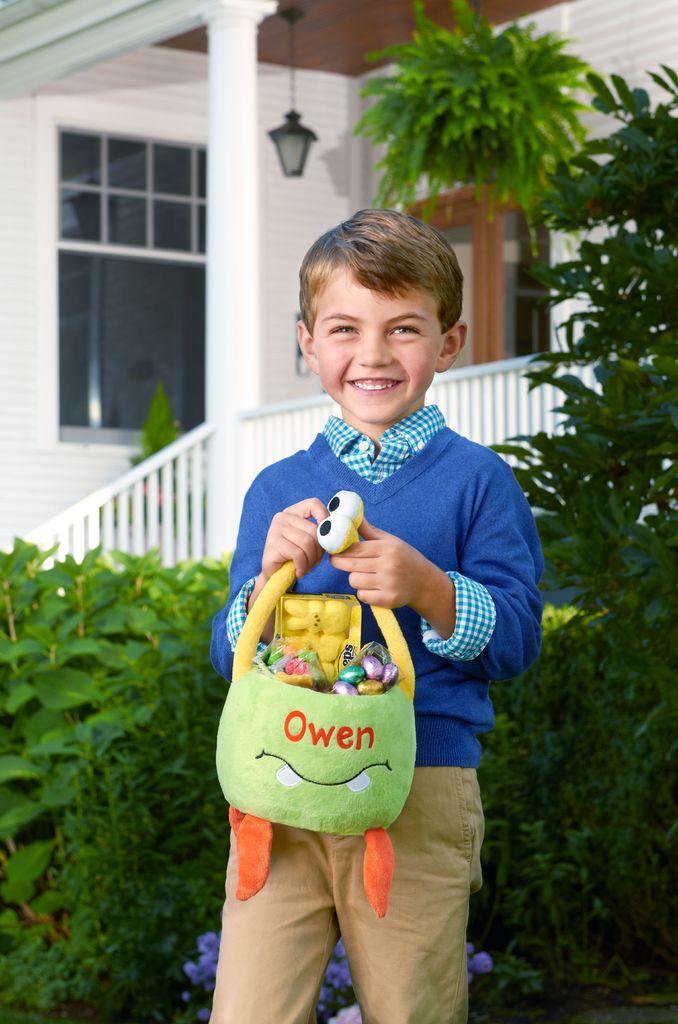Can you describe this image briefly? In this image there is a boy who is standing on the ground by holding the toys. He is smiling. In the background there is a house. Behind the boy there are plants. There is a staircase in front of the house. There is a light which is attached to the roof of the house. 